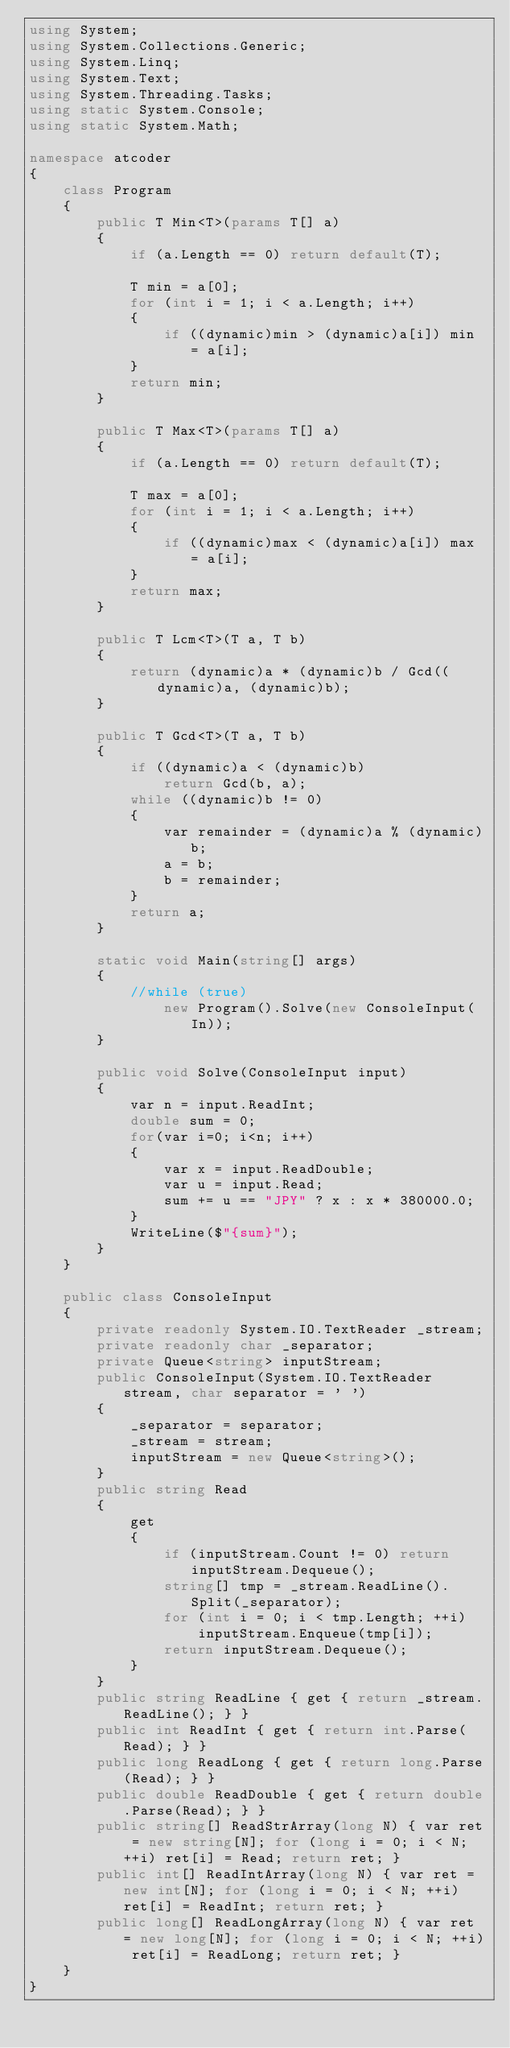<code> <loc_0><loc_0><loc_500><loc_500><_C#_>using System;
using System.Collections.Generic;
using System.Linq;
using System.Text;
using System.Threading.Tasks;
using static System.Console;
using static System.Math;

namespace atcoder
{
    class Program
    {
        public T Min<T>(params T[] a)
        {
            if (a.Length == 0) return default(T);

            T min = a[0];
            for (int i = 1; i < a.Length; i++)
            {
                if ((dynamic)min > (dynamic)a[i]) min = a[i];
            }
            return min;
        }

        public T Max<T>(params T[] a)
        {
            if (a.Length == 0) return default(T);

            T max = a[0];
            for (int i = 1; i < a.Length; i++)
            {
                if ((dynamic)max < (dynamic)a[i]) max = a[i];
            }
            return max;
        }

        public T Lcm<T>(T a, T b)
        {
            return (dynamic)a * (dynamic)b / Gcd((dynamic)a, (dynamic)b);
        }

        public T Gcd<T>(T a, T b)
        {
            if ((dynamic)a < (dynamic)b)
                return Gcd(b, a);
            while ((dynamic)b != 0)
            {
                var remainder = (dynamic)a % (dynamic)b;
                a = b;
                b = remainder;
            }
            return a;
        }

        static void Main(string[] args)
        {
            //while (true)
                new Program().Solve(new ConsoleInput(In));
        }

        public void Solve(ConsoleInput input)
        {
            var n = input.ReadInt;
            double sum = 0;
            for(var i=0; i<n; i++)
            {
                var x = input.ReadDouble;
                var u = input.Read;
                sum += u == "JPY" ? x : x * 380000.0;
            }
            WriteLine($"{sum}");
        }
    }

    public class ConsoleInput
    {
        private readonly System.IO.TextReader _stream;
        private readonly char _separator;
        private Queue<string> inputStream;
        public ConsoleInput(System.IO.TextReader stream, char separator = ' ')
        {
            _separator = separator;
            _stream = stream;
            inputStream = new Queue<string>();
        }
        public string Read
        {
            get
            {
                if (inputStream.Count != 0) return inputStream.Dequeue();
                string[] tmp = _stream.ReadLine().Split(_separator);
                for (int i = 0; i < tmp.Length; ++i)
                    inputStream.Enqueue(tmp[i]);
                return inputStream.Dequeue();
            }
        }
        public string ReadLine { get { return _stream.ReadLine(); } }
        public int ReadInt { get { return int.Parse(Read); } }
        public long ReadLong { get { return long.Parse(Read); } }
        public double ReadDouble { get { return double.Parse(Read); } }
        public string[] ReadStrArray(long N) { var ret = new string[N]; for (long i = 0; i < N; ++i) ret[i] = Read; return ret; }
        public int[] ReadIntArray(long N) { var ret = new int[N]; for (long i = 0; i < N; ++i) ret[i] = ReadInt; return ret; }
        public long[] ReadLongArray(long N) { var ret = new long[N]; for (long i = 0; i < N; ++i) ret[i] = ReadLong; return ret; }
    }
}
</code> 